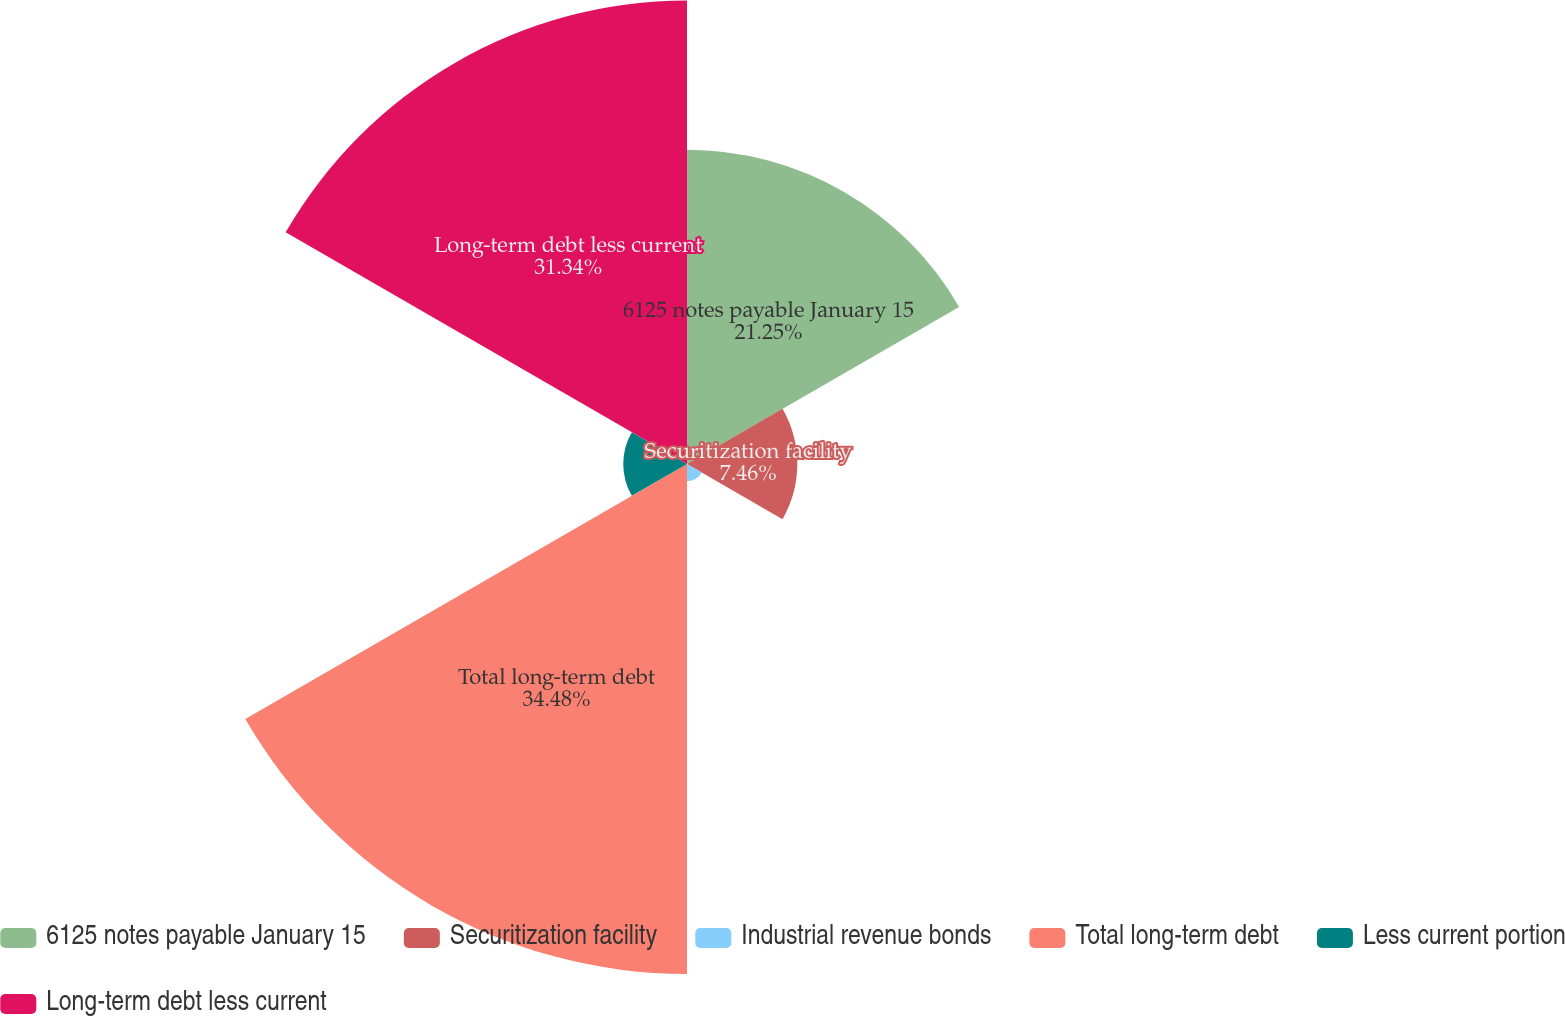<chart> <loc_0><loc_0><loc_500><loc_500><pie_chart><fcel>6125 notes payable January 15<fcel>Securitization facility<fcel>Industrial revenue bonds<fcel>Total long-term debt<fcel>Less current portion<fcel>Long-term debt less current<nl><fcel>21.25%<fcel>7.46%<fcel>1.16%<fcel>34.49%<fcel>4.31%<fcel>31.34%<nl></chart> 